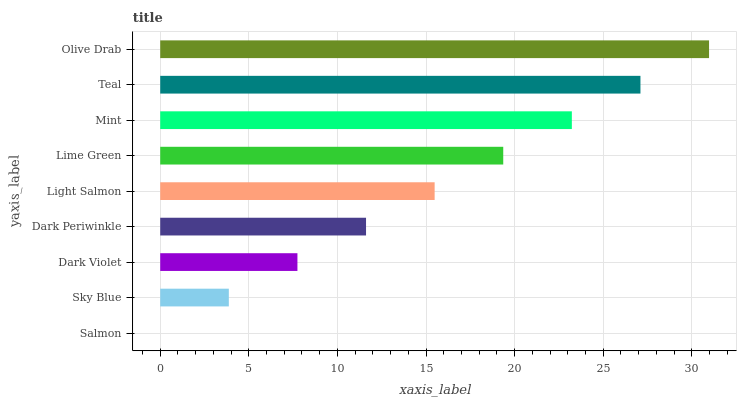Is Salmon the minimum?
Answer yes or no. Yes. Is Olive Drab the maximum?
Answer yes or no. Yes. Is Sky Blue the minimum?
Answer yes or no. No. Is Sky Blue the maximum?
Answer yes or no. No. Is Sky Blue greater than Salmon?
Answer yes or no. Yes. Is Salmon less than Sky Blue?
Answer yes or no. Yes. Is Salmon greater than Sky Blue?
Answer yes or no. No. Is Sky Blue less than Salmon?
Answer yes or no. No. Is Light Salmon the high median?
Answer yes or no. Yes. Is Light Salmon the low median?
Answer yes or no. Yes. Is Dark Violet the high median?
Answer yes or no. No. Is Dark Periwinkle the low median?
Answer yes or no. No. 